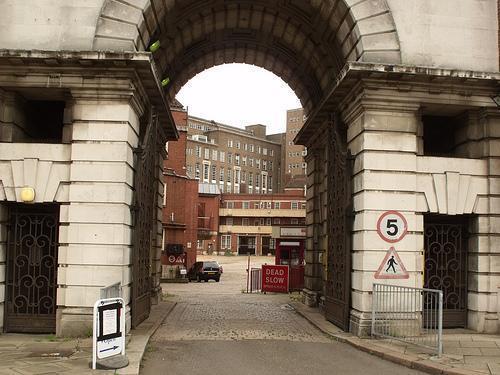How many traffic signs are attached to the arch?
Give a very brief answer. 2. 